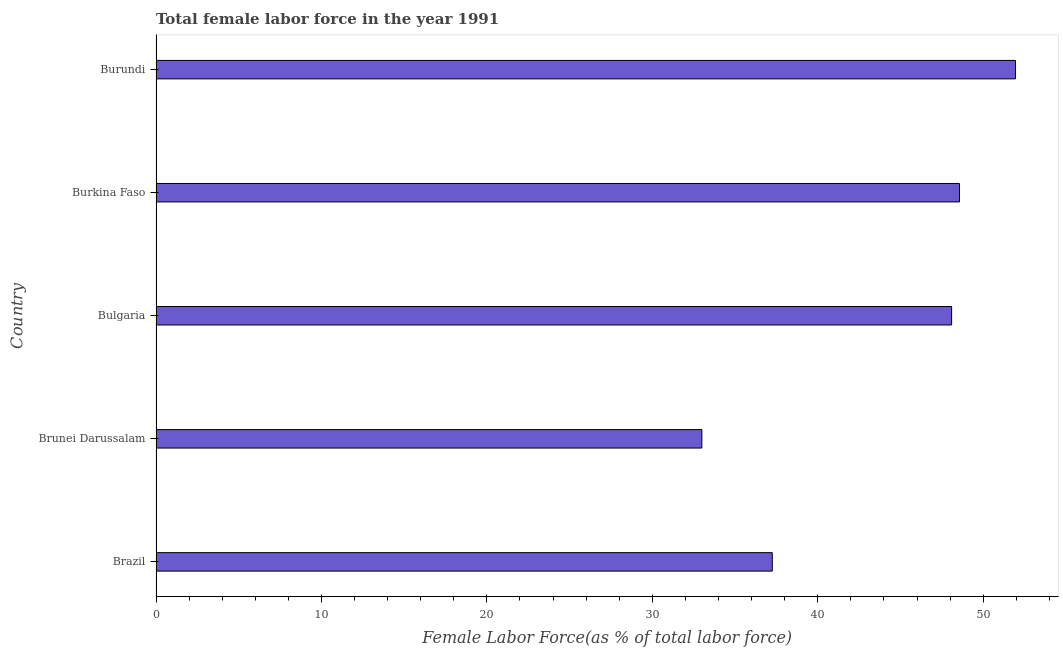Does the graph contain any zero values?
Make the answer very short. No. What is the title of the graph?
Your answer should be compact. Total female labor force in the year 1991. What is the label or title of the X-axis?
Keep it short and to the point. Female Labor Force(as % of total labor force). What is the total female labor force in Burkina Faso?
Your answer should be compact. 48.57. Across all countries, what is the maximum total female labor force?
Provide a succinct answer. 51.96. Across all countries, what is the minimum total female labor force?
Your answer should be very brief. 33. In which country was the total female labor force maximum?
Give a very brief answer. Burundi. In which country was the total female labor force minimum?
Provide a short and direct response. Brunei Darussalam. What is the sum of the total female labor force?
Make the answer very short. 218.86. What is the difference between the total female labor force in Burkina Faso and Burundi?
Provide a succinct answer. -3.39. What is the average total female labor force per country?
Make the answer very short. 43.77. What is the median total female labor force?
Provide a succinct answer. 48.09. What is the ratio of the total female labor force in Brazil to that in Brunei Darussalam?
Your response must be concise. 1.13. What is the difference between the highest and the second highest total female labor force?
Your answer should be compact. 3.39. Is the sum of the total female labor force in Brazil and Bulgaria greater than the maximum total female labor force across all countries?
Your answer should be compact. Yes. What is the difference between the highest and the lowest total female labor force?
Offer a terse response. 18.96. How many bars are there?
Your answer should be compact. 5. Are all the bars in the graph horizontal?
Offer a terse response. Yes. How many countries are there in the graph?
Give a very brief answer. 5. Are the values on the major ticks of X-axis written in scientific E-notation?
Provide a succinct answer. No. What is the Female Labor Force(as % of total labor force) in Brazil?
Your answer should be compact. 37.25. What is the Female Labor Force(as % of total labor force) in Brunei Darussalam?
Your response must be concise. 33. What is the Female Labor Force(as % of total labor force) in Bulgaria?
Your answer should be compact. 48.09. What is the Female Labor Force(as % of total labor force) of Burkina Faso?
Provide a short and direct response. 48.57. What is the Female Labor Force(as % of total labor force) of Burundi?
Provide a short and direct response. 51.96. What is the difference between the Female Labor Force(as % of total labor force) in Brazil and Brunei Darussalam?
Offer a terse response. 4.26. What is the difference between the Female Labor Force(as % of total labor force) in Brazil and Bulgaria?
Your answer should be compact. -10.84. What is the difference between the Female Labor Force(as % of total labor force) in Brazil and Burkina Faso?
Offer a terse response. -11.31. What is the difference between the Female Labor Force(as % of total labor force) in Brazil and Burundi?
Make the answer very short. -14.7. What is the difference between the Female Labor Force(as % of total labor force) in Brunei Darussalam and Bulgaria?
Your answer should be very brief. -15.1. What is the difference between the Female Labor Force(as % of total labor force) in Brunei Darussalam and Burkina Faso?
Provide a succinct answer. -15.57. What is the difference between the Female Labor Force(as % of total labor force) in Brunei Darussalam and Burundi?
Keep it short and to the point. -18.96. What is the difference between the Female Labor Force(as % of total labor force) in Bulgaria and Burkina Faso?
Make the answer very short. -0.48. What is the difference between the Female Labor Force(as % of total labor force) in Bulgaria and Burundi?
Provide a short and direct response. -3.86. What is the difference between the Female Labor Force(as % of total labor force) in Burkina Faso and Burundi?
Offer a very short reply. -3.39. What is the ratio of the Female Labor Force(as % of total labor force) in Brazil to that in Brunei Darussalam?
Offer a terse response. 1.13. What is the ratio of the Female Labor Force(as % of total labor force) in Brazil to that in Bulgaria?
Provide a short and direct response. 0.78. What is the ratio of the Female Labor Force(as % of total labor force) in Brazil to that in Burkina Faso?
Provide a succinct answer. 0.77. What is the ratio of the Female Labor Force(as % of total labor force) in Brazil to that in Burundi?
Offer a terse response. 0.72. What is the ratio of the Female Labor Force(as % of total labor force) in Brunei Darussalam to that in Bulgaria?
Provide a succinct answer. 0.69. What is the ratio of the Female Labor Force(as % of total labor force) in Brunei Darussalam to that in Burkina Faso?
Keep it short and to the point. 0.68. What is the ratio of the Female Labor Force(as % of total labor force) in Brunei Darussalam to that in Burundi?
Provide a short and direct response. 0.64. What is the ratio of the Female Labor Force(as % of total labor force) in Bulgaria to that in Burundi?
Provide a succinct answer. 0.93. What is the ratio of the Female Labor Force(as % of total labor force) in Burkina Faso to that in Burundi?
Ensure brevity in your answer.  0.94. 